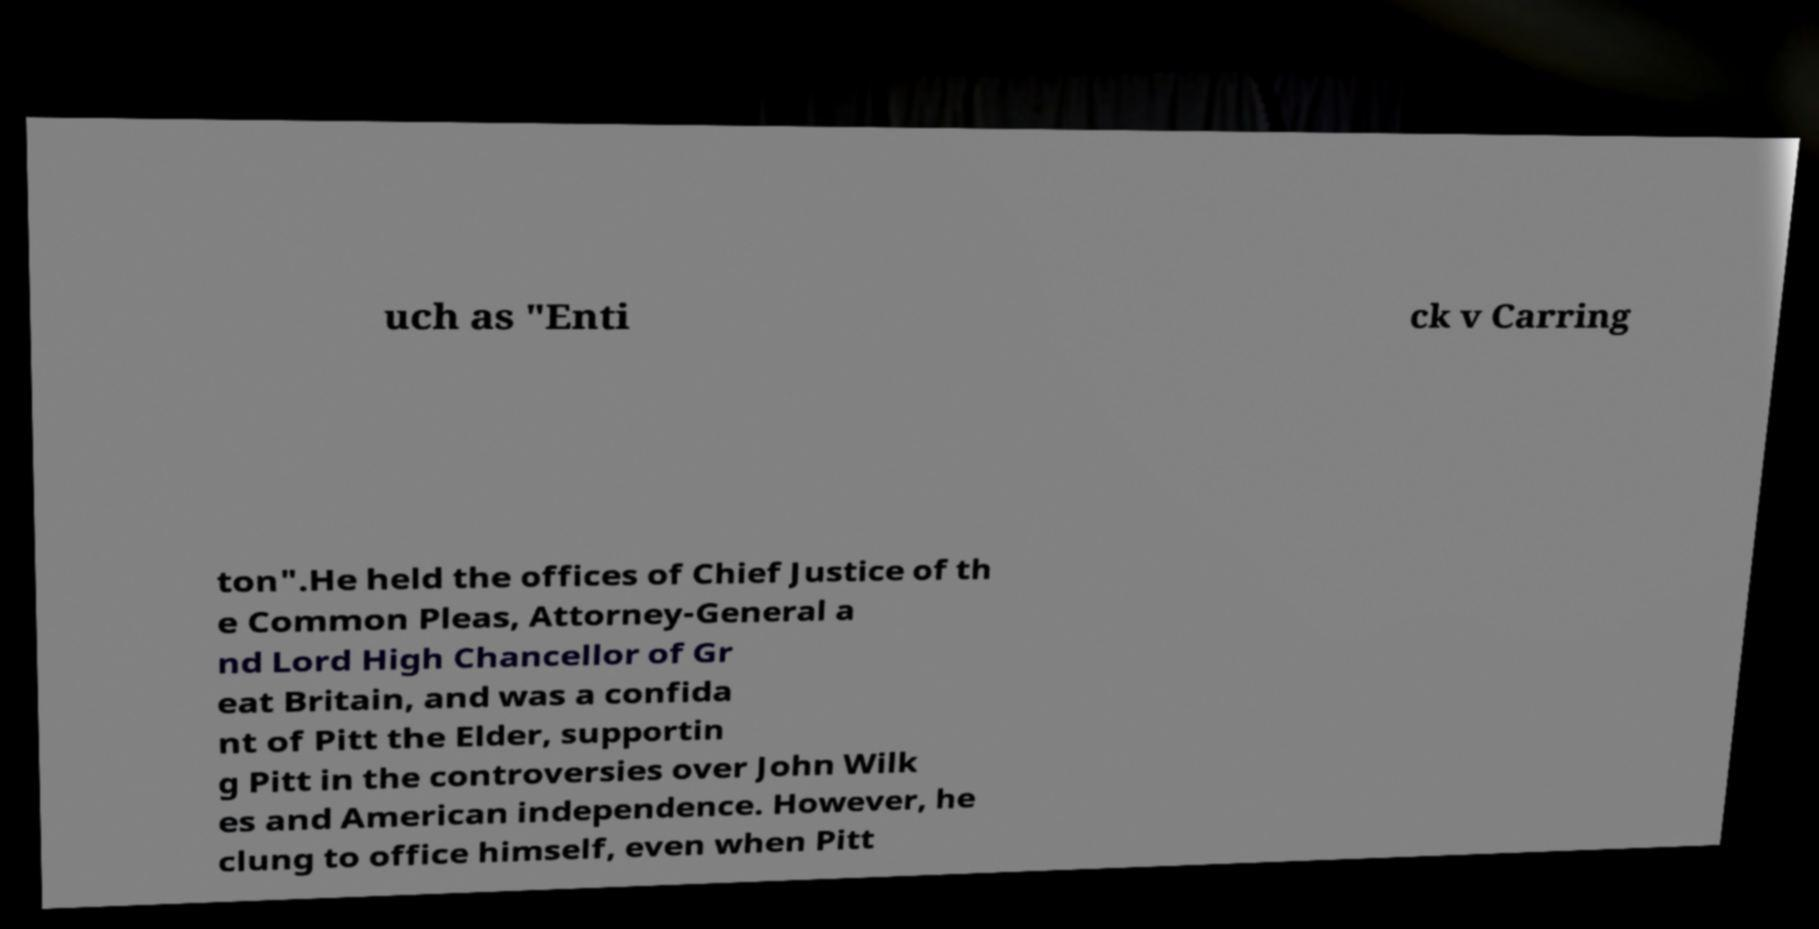Could you extract and type out the text from this image? uch as "Enti ck v Carring ton".He held the offices of Chief Justice of th e Common Pleas, Attorney-General a nd Lord High Chancellor of Gr eat Britain, and was a confida nt of Pitt the Elder, supportin g Pitt in the controversies over John Wilk es and American independence. However, he clung to office himself, even when Pitt 